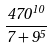<formula> <loc_0><loc_0><loc_500><loc_500>\frac { 4 7 0 ^ { 1 0 } } { 7 + 9 ^ { 5 } }</formula> 